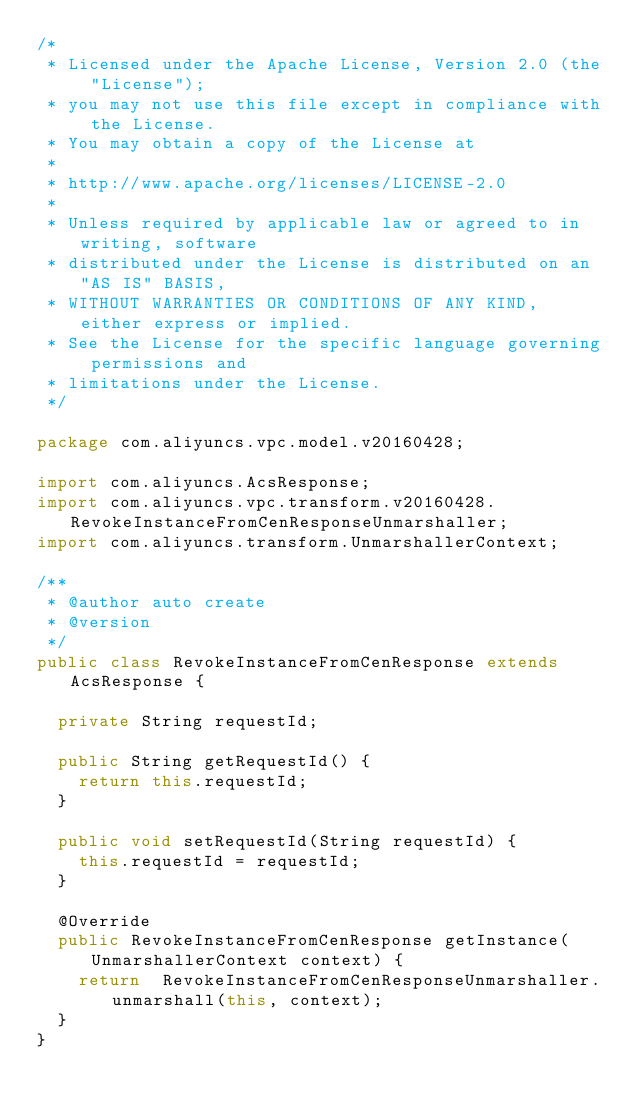<code> <loc_0><loc_0><loc_500><loc_500><_Java_>/*
 * Licensed under the Apache License, Version 2.0 (the "License");
 * you may not use this file except in compliance with the License.
 * You may obtain a copy of the License at
 *
 * http://www.apache.org/licenses/LICENSE-2.0
 *
 * Unless required by applicable law or agreed to in writing, software
 * distributed under the License is distributed on an "AS IS" BASIS,
 * WITHOUT WARRANTIES OR CONDITIONS OF ANY KIND, either express or implied.
 * See the License for the specific language governing permissions and
 * limitations under the License.
 */

package com.aliyuncs.vpc.model.v20160428;

import com.aliyuncs.AcsResponse;
import com.aliyuncs.vpc.transform.v20160428.RevokeInstanceFromCenResponseUnmarshaller;
import com.aliyuncs.transform.UnmarshallerContext;

/**
 * @author auto create
 * @version 
 */
public class RevokeInstanceFromCenResponse extends AcsResponse {

	private String requestId;

	public String getRequestId() {
		return this.requestId;
	}

	public void setRequestId(String requestId) {
		this.requestId = requestId;
	}

	@Override
	public RevokeInstanceFromCenResponse getInstance(UnmarshallerContext context) {
		return	RevokeInstanceFromCenResponseUnmarshaller.unmarshall(this, context);
	}
}
</code> 